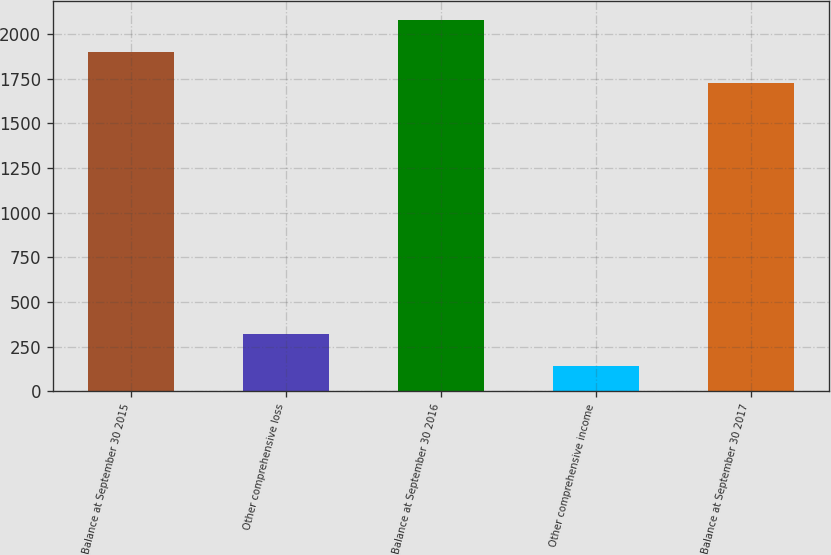<chart> <loc_0><loc_0><loc_500><loc_500><bar_chart><fcel>Balance at September 30 2015<fcel>Other comprehensive loss<fcel>Balance at September 30 2016<fcel>Other comprehensive income<fcel>Balance at September 30 2017<nl><fcel>1901.9<fcel>318.9<fcel>2080.8<fcel>140<fcel>1723<nl></chart> 